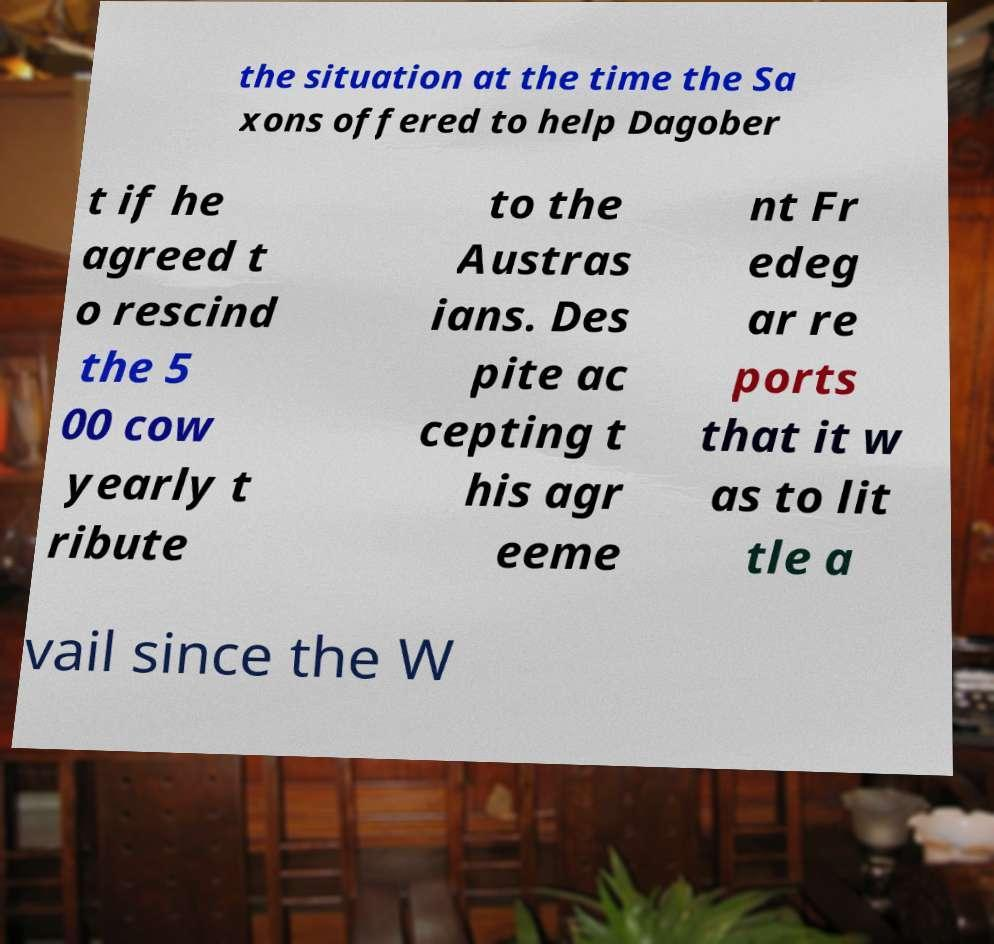There's text embedded in this image that I need extracted. Can you transcribe it verbatim? the situation at the time the Sa xons offered to help Dagober t if he agreed t o rescind the 5 00 cow yearly t ribute to the Austras ians. Des pite ac cepting t his agr eeme nt Fr edeg ar re ports that it w as to lit tle a vail since the W 